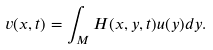<formula> <loc_0><loc_0><loc_500><loc_500>v ( x , t ) = \int _ { M } H ( x , y , t ) u ( y ) d y .</formula> 